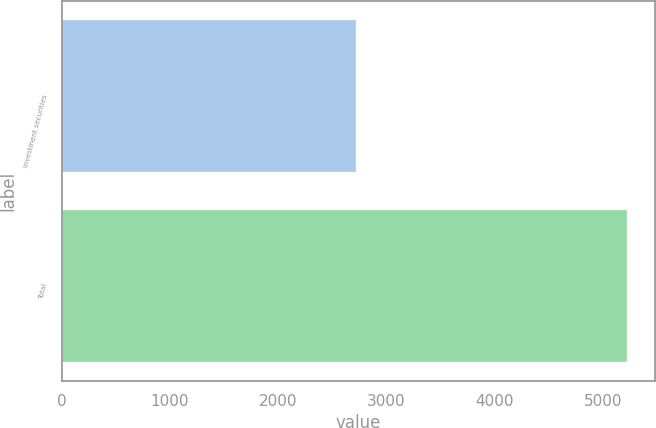Convert chart. <chart><loc_0><loc_0><loc_500><loc_500><bar_chart><fcel>Investment securities<fcel>Total<nl><fcel>2721<fcel>5221<nl></chart> 